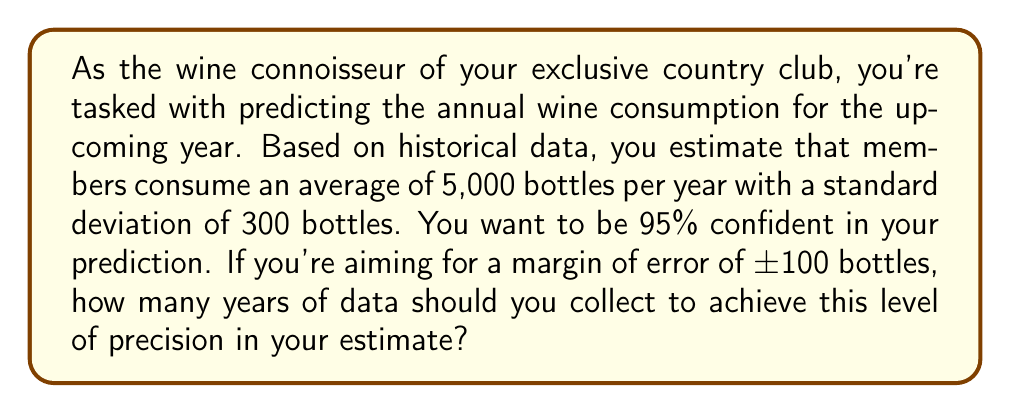Solve this math problem. Let's approach this step-by-step:

1) The formula for the margin of error (E) in a confidence interval is:

   $$E = z_{\alpha/2} \cdot \frac{\sigma}{\sqrt{n}}$$

   Where:
   - $z_{\alpha/2}$ is the critical value for the desired confidence level
   - $\sigma$ is the population standard deviation
   - $n$ is the sample size (in this case, the number of years of data)

2) We know:
   - Confidence level = 95%, so $z_{\alpha/2} = 1.96$
   - $\sigma = 300$ bottles
   - $E = 100$ bottles (the desired margin of error)

3) Let's substitute these values into the formula:

   $$100 = 1.96 \cdot \frac{300}{\sqrt{n}}$$

4) Now, let's solve for n:

   $$\sqrt{n} = 1.96 \cdot \frac{300}{100} = 5.88$$

   $$n = (5.88)^2 = 34.57$$

5) Since we can't have a fractional number of years, we round up to the nearest whole number.
Answer: 35 years 